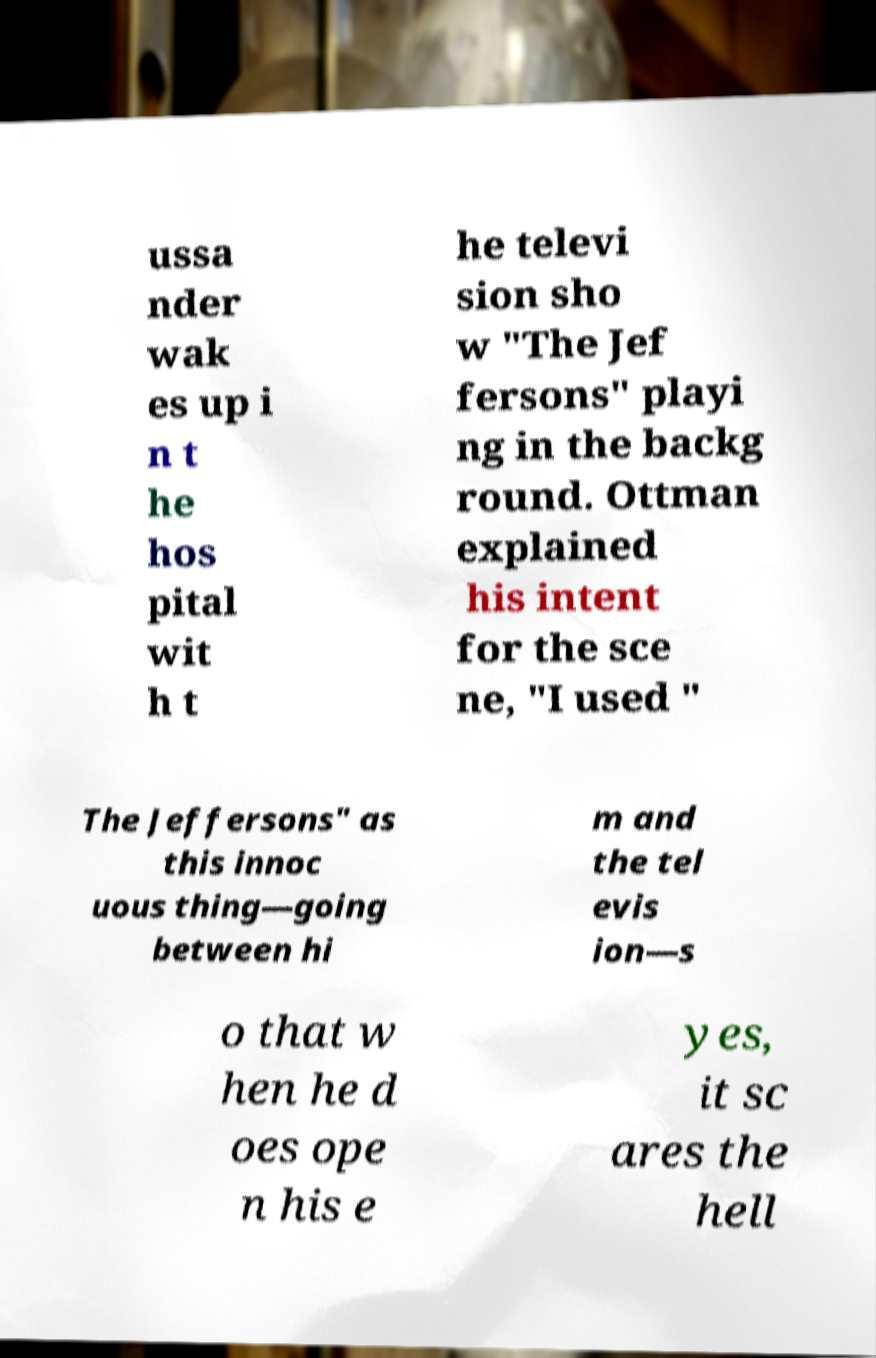There's text embedded in this image that I need extracted. Can you transcribe it verbatim? ussa nder wak es up i n t he hos pital wit h t he televi sion sho w "The Jef fersons" playi ng in the backg round. Ottman explained his intent for the sce ne, "I used " The Jeffersons" as this innoc uous thing—going between hi m and the tel evis ion—s o that w hen he d oes ope n his e yes, it sc ares the hell 